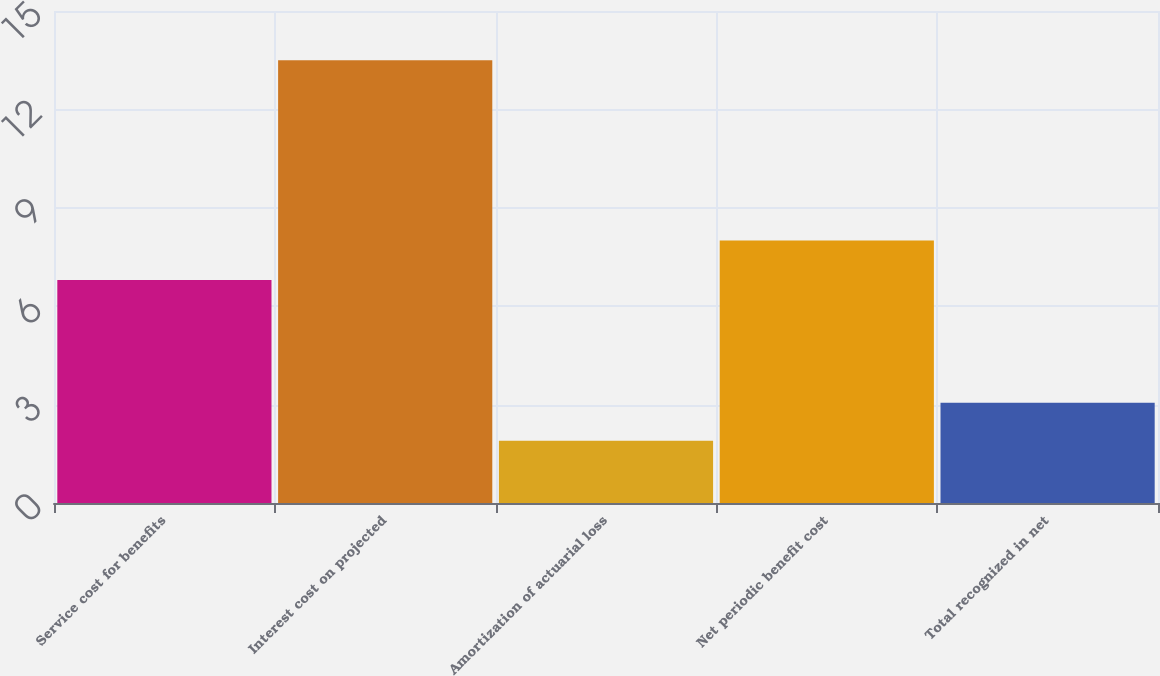Convert chart to OTSL. <chart><loc_0><loc_0><loc_500><loc_500><bar_chart><fcel>Service cost for benefits<fcel>Interest cost on projected<fcel>Amortization of actuarial loss<fcel>Net periodic benefit cost<fcel>Total recognized in net<nl><fcel>6.8<fcel>13.5<fcel>1.9<fcel>8<fcel>3.06<nl></chart> 